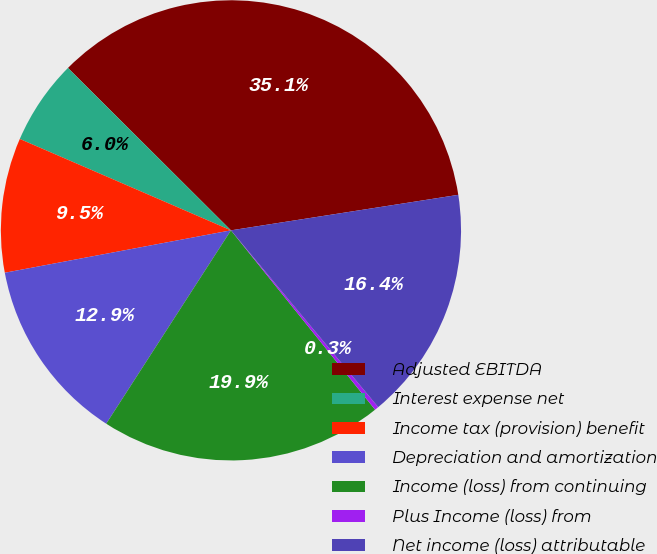Convert chart. <chart><loc_0><loc_0><loc_500><loc_500><pie_chart><fcel>Adjusted EBITDA<fcel>Interest expense net<fcel>Income tax (provision) benefit<fcel>Depreciation and amortization<fcel>Income (loss) from continuing<fcel>Plus Income (loss) from<fcel>Net income (loss) attributable<nl><fcel>35.06%<fcel>5.97%<fcel>9.45%<fcel>12.93%<fcel>19.89%<fcel>0.28%<fcel>16.41%<nl></chart> 